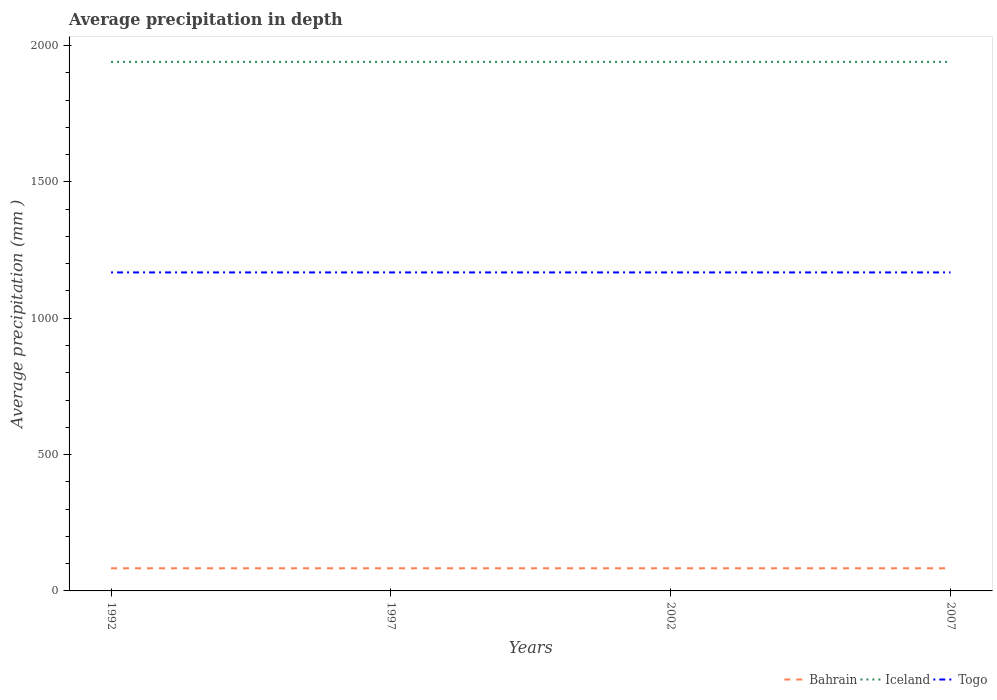How many different coloured lines are there?
Keep it short and to the point. 3. Does the line corresponding to Togo intersect with the line corresponding to Bahrain?
Offer a terse response. No. Is the number of lines equal to the number of legend labels?
Make the answer very short. Yes. Across all years, what is the maximum average precipitation in Bahrain?
Offer a terse response. 83. In which year was the average precipitation in Togo maximum?
Make the answer very short. 1992. What is the difference between the highest and the lowest average precipitation in Togo?
Make the answer very short. 0. How many years are there in the graph?
Offer a terse response. 4. Does the graph contain any zero values?
Provide a short and direct response. No. Does the graph contain grids?
Keep it short and to the point. No. How many legend labels are there?
Provide a succinct answer. 3. How are the legend labels stacked?
Your answer should be compact. Horizontal. What is the title of the graph?
Offer a very short reply. Average precipitation in depth. What is the label or title of the X-axis?
Ensure brevity in your answer.  Years. What is the label or title of the Y-axis?
Your response must be concise. Average precipitation (mm ). What is the Average precipitation (mm ) in Bahrain in 1992?
Provide a short and direct response. 83. What is the Average precipitation (mm ) of Iceland in 1992?
Give a very brief answer. 1940. What is the Average precipitation (mm ) in Togo in 1992?
Provide a succinct answer. 1168. What is the Average precipitation (mm ) of Bahrain in 1997?
Provide a short and direct response. 83. What is the Average precipitation (mm ) of Iceland in 1997?
Provide a short and direct response. 1940. What is the Average precipitation (mm ) in Togo in 1997?
Make the answer very short. 1168. What is the Average precipitation (mm ) in Iceland in 2002?
Make the answer very short. 1940. What is the Average precipitation (mm ) of Togo in 2002?
Give a very brief answer. 1168. What is the Average precipitation (mm ) of Bahrain in 2007?
Make the answer very short. 83. What is the Average precipitation (mm ) of Iceland in 2007?
Offer a very short reply. 1940. What is the Average precipitation (mm ) in Togo in 2007?
Offer a terse response. 1168. Across all years, what is the maximum Average precipitation (mm ) in Bahrain?
Ensure brevity in your answer.  83. Across all years, what is the maximum Average precipitation (mm ) in Iceland?
Your answer should be very brief. 1940. Across all years, what is the maximum Average precipitation (mm ) in Togo?
Provide a short and direct response. 1168. Across all years, what is the minimum Average precipitation (mm ) in Bahrain?
Your answer should be compact. 83. Across all years, what is the minimum Average precipitation (mm ) of Iceland?
Ensure brevity in your answer.  1940. Across all years, what is the minimum Average precipitation (mm ) in Togo?
Give a very brief answer. 1168. What is the total Average precipitation (mm ) of Bahrain in the graph?
Provide a succinct answer. 332. What is the total Average precipitation (mm ) in Iceland in the graph?
Offer a very short reply. 7760. What is the total Average precipitation (mm ) of Togo in the graph?
Provide a succinct answer. 4672. What is the difference between the Average precipitation (mm ) in Iceland in 1992 and that in 1997?
Offer a terse response. 0. What is the difference between the Average precipitation (mm ) in Togo in 1992 and that in 1997?
Give a very brief answer. 0. What is the difference between the Average precipitation (mm ) in Togo in 1992 and that in 2007?
Provide a short and direct response. 0. What is the difference between the Average precipitation (mm ) of Togo in 1997 and that in 2002?
Keep it short and to the point. 0. What is the difference between the Average precipitation (mm ) of Bahrain in 1997 and that in 2007?
Your answer should be compact. 0. What is the difference between the Average precipitation (mm ) in Iceland in 1997 and that in 2007?
Give a very brief answer. 0. What is the difference between the Average precipitation (mm ) in Bahrain in 2002 and that in 2007?
Keep it short and to the point. 0. What is the difference between the Average precipitation (mm ) in Iceland in 2002 and that in 2007?
Your answer should be compact. 0. What is the difference between the Average precipitation (mm ) in Togo in 2002 and that in 2007?
Make the answer very short. 0. What is the difference between the Average precipitation (mm ) in Bahrain in 1992 and the Average precipitation (mm ) in Iceland in 1997?
Give a very brief answer. -1857. What is the difference between the Average precipitation (mm ) of Bahrain in 1992 and the Average precipitation (mm ) of Togo in 1997?
Your answer should be compact. -1085. What is the difference between the Average precipitation (mm ) of Iceland in 1992 and the Average precipitation (mm ) of Togo in 1997?
Provide a short and direct response. 772. What is the difference between the Average precipitation (mm ) of Bahrain in 1992 and the Average precipitation (mm ) of Iceland in 2002?
Ensure brevity in your answer.  -1857. What is the difference between the Average precipitation (mm ) in Bahrain in 1992 and the Average precipitation (mm ) in Togo in 2002?
Offer a very short reply. -1085. What is the difference between the Average precipitation (mm ) of Iceland in 1992 and the Average precipitation (mm ) of Togo in 2002?
Ensure brevity in your answer.  772. What is the difference between the Average precipitation (mm ) of Bahrain in 1992 and the Average precipitation (mm ) of Iceland in 2007?
Keep it short and to the point. -1857. What is the difference between the Average precipitation (mm ) of Bahrain in 1992 and the Average precipitation (mm ) of Togo in 2007?
Provide a succinct answer. -1085. What is the difference between the Average precipitation (mm ) of Iceland in 1992 and the Average precipitation (mm ) of Togo in 2007?
Give a very brief answer. 772. What is the difference between the Average precipitation (mm ) in Bahrain in 1997 and the Average precipitation (mm ) in Iceland in 2002?
Offer a terse response. -1857. What is the difference between the Average precipitation (mm ) of Bahrain in 1997 and the Average precipitation (mm ) of Togo in 2002?
Ensure brevity in your answer.  -1085. What is the difference between the Average precipitation (mm ) in Iceland in 1997 and the Average precipitation (mm ) in Togo in 2002?
Provide a short and direct response. 772. What is the difference between the Average precipitation (mm ) in Bahrain in 1997 and the Average precipitation (mm ) in Iceland in 2007?
Your answer should be compact. -1857. What is the difference between the Average precipitation (mm ) in Bahrain in 1997 and the Average precipitation (mm ) in Togo in 2007?
Your answer should be compact. -1085. What is the difference between the Average precipitation (mm ) in Iceland in 1997 and the Average precipitation (mm ) in Togo in 2007?
Your answer should be very brief. 772. What is the difference between the Average precipitation (mm ) in Bahrain in 2002 and the Average precipitation (mm ) in Iceland in 2007?
Give a very brief answer. -1857. What is the difference between the Average precipitation (mm ) in Bahrain in 2002 and the Average precipitation (mm ) in Togo in 2007?
Make the answer very short. -1085. What is the difference between the Average precipitation (mm ) in Iceland in 2002 and the Average precipitation (mm ) in Togo in 2007?
Provide a succinct answer. 772. What is the average Average precipitation (mm ) in Iceland per year?
Ensure brevity in your answer.  1940. What is the average Average precipitation (mm ) in Togo per year?
Give a very brief answer. 1168. In the year 1992, what is the difference between the Average precipitation (mm ) in Bahrain and Average precipitation (mm ) in Iceland?
Ensure brevity in your answer.  -1857. In the year 1992, what is the difference between the Average precipitation (mm ) in Bahrain and Average precipitation (mm ) in Togo?
Offer a very short reply. -1085. In the year 1992, what is the difference between the Average precipitation (mm ) of Iceland and Average precipitation (mm ) of Togo?
Ensure brevity in your answer.  772. In the year 1997, what is the difference between the Average precipitation (mm ) in Bahrain and Average precipitation (mm ) in Iceland?
Ensure brevity in your answer.  -1857. In the year 1997, what is the difference between the Average precipitation (mm ) of Bahrain and Average precipitation (mm ) of Togo?
Your response must be concise. -1085. In the year 1997, what is the difference between the Average precipitation (mm ) of Iceland and Average precipitation (mm ) of Togo?
Offer a terse response. 772. In the year 2002, what is the difference between the Average precipitation (mm ) of Bahrain and Average precipitation (mm ) of Iceland?
Offer a very short reply. -1857. In the year 2002, what is the difference between the Average precipitation (mm ) of Bahrain and Average precipitation (mm ) of Togo?
Your answer should be compact. -1085. In the year 2002, what is the difference between the Average precipitation (mm ) of Iceland and Average precipitation (mm ) of Togo?
Your answer should be very brief. 772. In the year 2007, what is the difference between the Average precipitation (mm ) of Bahrain and Average precipitation (mm ) of Iceland?
Your response must be concise. -1857. In the year 2007, what is the difference between the Average precipitation (mm ) in Bahrain and Average precipitation (mm ) in Togo?
Your answer should be compact. -1085. In the year 2007, what is the difference between the Average precipitation (mm ) of Iceland and Average precipitation (mm ) of Togo?
Provide a short and direct response. 772. What is the ratio of the Average precipitation (mm ) in Bahrain in 1992 to that in 1997?
Offer a very short reply. 1. What is the ratio of the Average precipitation (mm ) of Iceland in 1992 to that in 1997?
Offer a very short reply. 1. What is the ratio of the Average precipitation (mm ) of Bahrain in 1992 to that in 2002?
Give a very brief answer. 1. What is the ratio of the Average precipitation (mm ) in Iceland in 1992 to that in 2002?
Offer a very short reply. 1. What is the ratio of the Average precipitation (mm ) of Bahrain in 1992 to that in 2007?
Keep it short and to the point. 1. What is the ratio of the Average precipitation (mm ) of Togo in 1992 to that in 2007?
Provide a succinct answer. 1. What is the ratio of the Average precipitation (mm ) in Bahrain in 1997 to that in 2002?
Make the answer very short. 1. What is the ratio of the Average precipitation (mm ) in Iceland in 1997 to that in 2002?
Provide a short and direct response. 1. What is the ratio of the Average precipitation (mm ) in Togo in 1997 to that in 2002?
Keep it short and to the point. 1. What is the ratio of the Average precipitation (mm ) in Bahrain in 1997 to that in 2007?
Offer a very short reply. 1. What is the ratio of the Average precipitation (mm ) of Iceland in 1997 to that in 2007?
Offer a very short reply. 1. What is the ratio of the Average precipitation (mm ) in Bahrain in 2002 to that in 2007?
Give a very brief answer. 1. What is the ratio of the Average precipitation (mm ) in Iceland in 2002 to that in 2007?
Offer a very short reply. 1. What is the ratio of the Average precipitation (mm ) in Togo in 2002 to that in 2007?
Your response must be concise. 1. What is the difference between the highest and the second highest Average precipitation (mm ) in Iceland?
Ensure brevity in your answer.  0. What is the difference between the highest and the lowest Average precipitation (mm ) in Togo?
Keep it short and to the point. 0. 